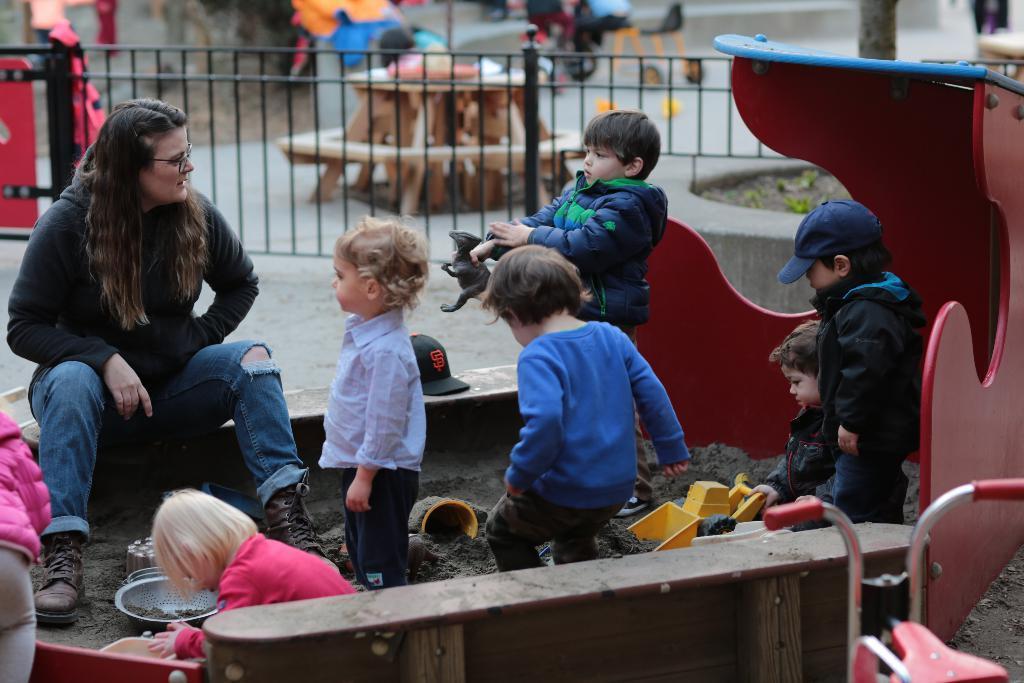Please provide a concise description of this image. This is the picture of a lady who is sitting on the path and also some kids who are playing with mud and behind there is a fencing and some other things around. 